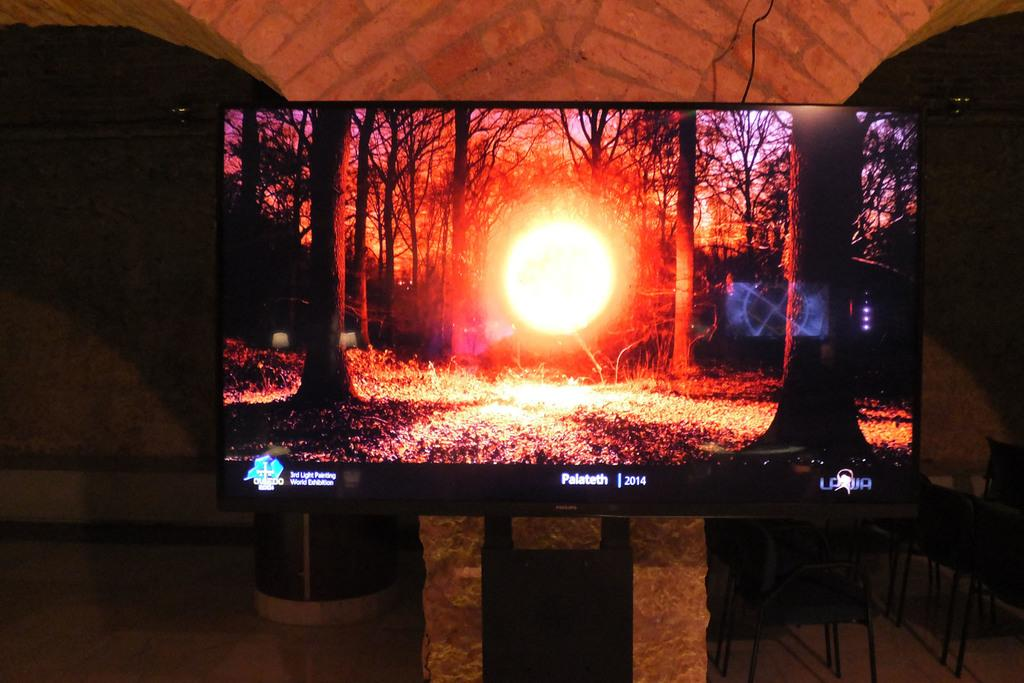Provide a one-sentence caption for the provided image. A Phillips TV is showing an image of the sun through the trees and Palateth 2014 at the bottom. 